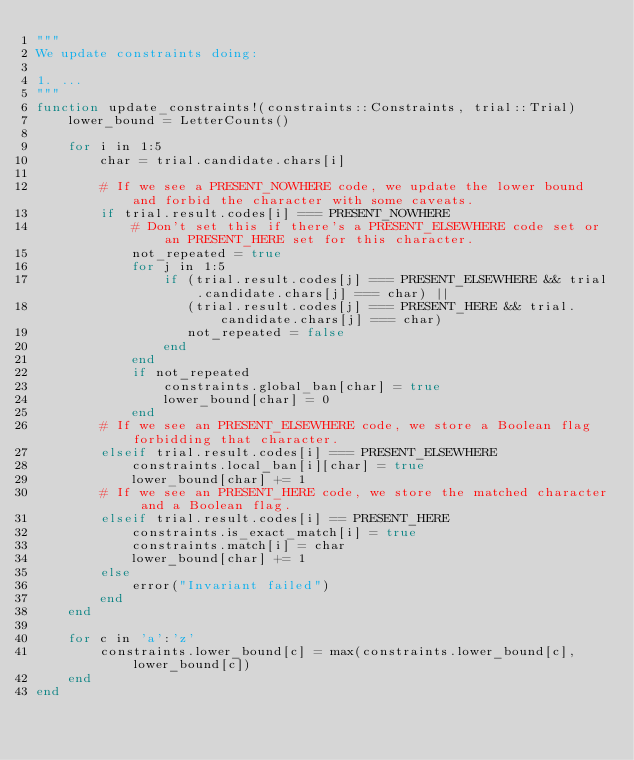<code> <loc_0><loc_0><loc_500><loc_500><_Julia_>"""
We update constraints doing:

1. ...
"""
function update_constraints!(constraints::Constraints, trial::Trial)
    lower_bound = LetterCounts()

    for i in 1:5
        char = trial.candidate.chars[i]

        # If we see a PRESENT_NOWHERE code, we update the lower bound and forbid the character with some caveats.
        if trial.result.codes[i] === PRESENT_NOWHERE
            # Don't set this if there's a PRESENT_ELSEWHERE code set or an PRESENT_HERE set for this character.
            not_repeated = true
            for j in 1:5
                if (trial.result.codes[j] === PRESENT_ELSEWHERE && trial.candidate.chars[j] === char) ||
                   (trial.result.codes[j] === PRESENT_HERE && trial.candidate.chars[j] === char)
                   not_repeated = false
                end
            end
            if not_repeated
                constraints.global_ban[char] = true
                lower_bound[char] = 0
            end
        # If we see an PRESENT_ELSEWHERE code, we store a Boolean flag forbidding that character.
        elseif trial.result.codes[i] === PRESENT_ELSEWHERE
            constraints.local_ban[i][char] = true
            lower_bound[char] += 1
        # If we see an PRESENT_HERE code, we store the matched character and a Boolean flag.
        elseif trial.result.codes[i] == PRESENT_HERE
            constraints.is_exact_match[i] = true
            constraints.match[i] = char
            lower_bound[char] += 1
        else
            error("Invariant failed")
        end
    end

    for c in 'a':'z'
        constraints.lower_bound[c] = max(constraints.lower_bound[c], lower_bound[c])
    end
end
</code> 